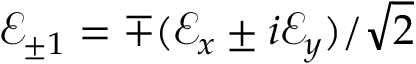Convert formula to latex. <formula><loc_0><loc_0><loc_500><loc_500>\mathcal { E } _ { \pm 1 } = \mp ( \mathcal { E } _ { x } \pm i \mathcal { E } _ { y } ) / \sqrt { 2 }</formula> 